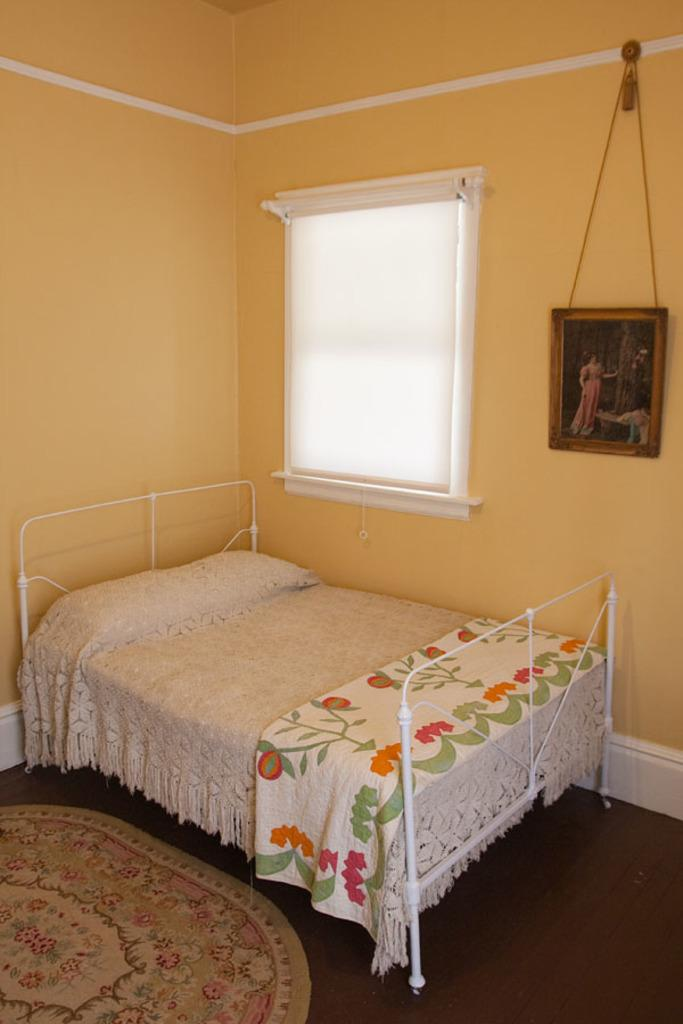What type of furniture is present in the image? There is a bed in the image. What is on the floor in the image? There is a carpet on the floor in the image. What architectural feature is present on the wall in the image? There is a window on the wall in the image. What type of church can be seen in the image? There is no church present in the image; it features a bed, carpet, and window. What action is the heart performing in the image? There is no heart present in the image, so it is not possible to determine any actions it might be performing. 